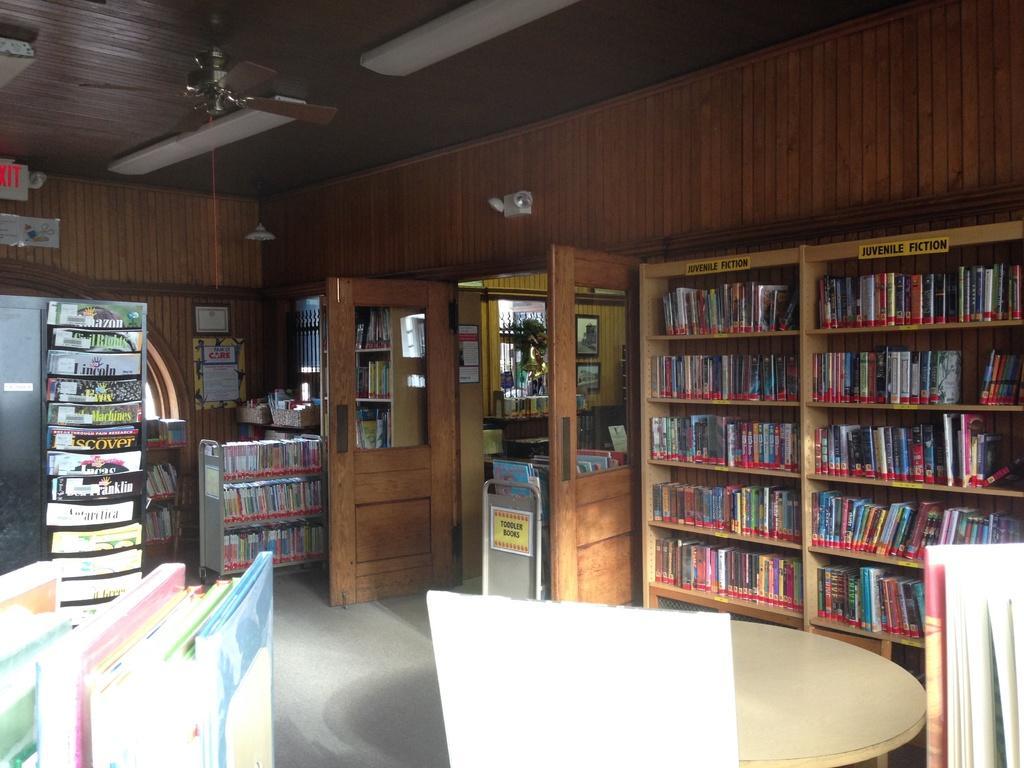Describe this image in one or two sentences. In this picture we can see the floor, table, books, doors, walls, some books on shelves, fan, ceiling and some objects. 